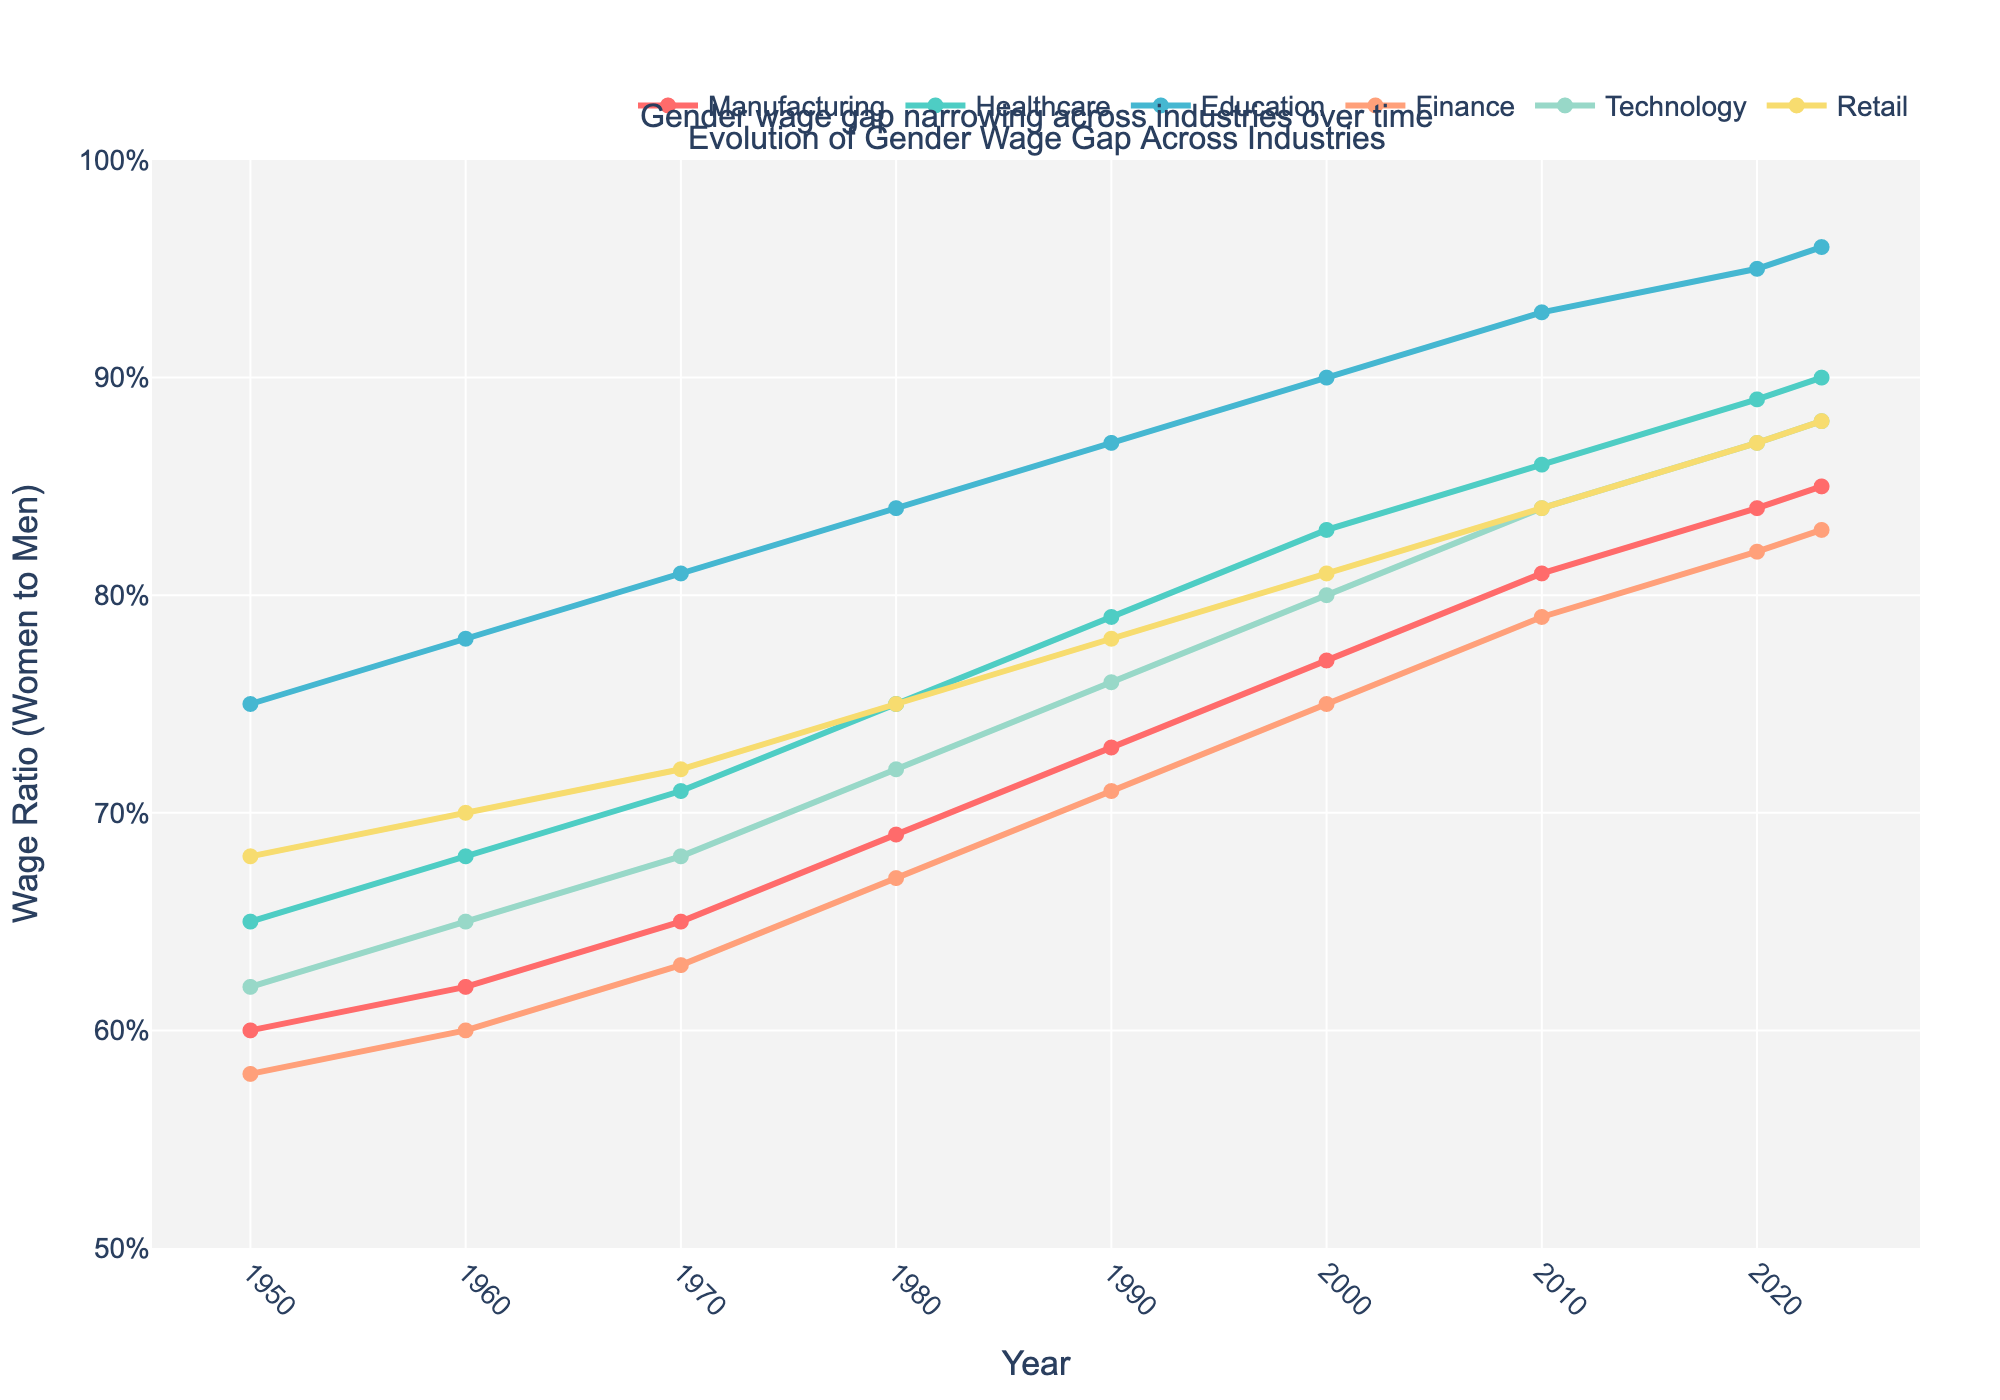What year did the wage ratio in the Healthcare industry surpass 0.85? In the Healthcare industry data, look for the first year where the ratio exceeds 0.85. This happens in 2010 when the ratio reaches 0.86.
Answer: 2010 Which industry had the smallest wage gap in 1950? Compare the wage ratios for all industries in 1950. The highest ratio indicates the smallest wage gap. Education, with a ratio of 0.75, had the smallest wage gap.
Answer: Education By how much did the wage ratio in Manufacturing increase from 1950 to 2023? Subtract the wage ratio of Manufacturing in 1950 (0.60) from its ratio in 2023 (0.85). The difference is 0.85 - 0.60 = 0.25.
Answer: 0.25 Which industry saw the greatest increase in the wage ratio from 1950 to 2023? Calculate the difference for each industry between the ratios in 1950 and 2023. Manufacturing: 0.85 - 0.60 = 0.25, Healthcare: 0.90 - 0.65 = 0.25, Education: 0.96 - 0.75 = 0.21, Finance: 0.83 - 0.58 = 0.25, Technology: 0.88 - 0.62 = 0.26, Retail: 0.88 - 0.68 = 0.20. Technology experienced the greatest increase of 0.26.
Answer: Technology What is the average wage ratio across all industries in 2023? Sum the wage ratios of all industries in 2023 (0.85 + 0.90 + 0.96 + 0.83 + 0.88 + 0.88) and divide by the number of industries, which is 6. Average = (0.85 + 0.90 + 0.96 + 0.83 + 0.88 + 0.88) / 6 = 0.88.
Answer: 0.88 